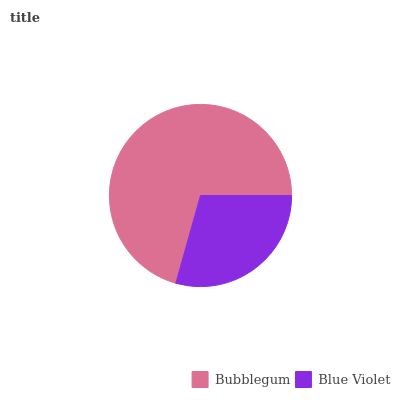Is Blue Violet the minimum?
Answer yes or no. Yes. Is Bubblegum the maximum?
Answer yes or no. Yes. Is Blue Violet the maximum?
Answer yes or no. No. Is Bubblegum greater than Blue Violet?
Answer yes or no. Yes. Is Blue Violet less than Bubblegum?
Answer yes or no. Yes. Is Blue Violet greater than Bubblegum?
Answer yes or no. No. Is Bubblegum less than Blue Violet?
Answer yes or no. No. Is Bubblegum the high median?
Answer yes or no. Yes. Is Blue Violet the low median?
Answer yes or no. Yes. Is Blue Violet the high median?
Answer yes or no. No. Is Bubblegum the low median?
Answer yes or no. No. 